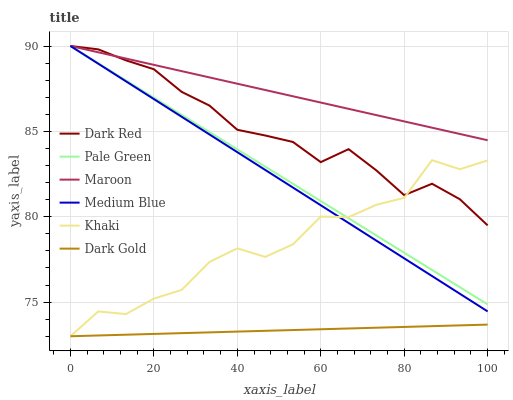Does Dark Gold have the minimum area under the curve?
Answer yes or no. Yes. Does Maroon have the maximum area under the curve?
Answer yes or no. Yes. Does Dark Red have the minimum area under the curve?
Answer yes or no. No. Does Dark Red have the maximum area under the curve?
Answer yes or no. No. Is Maroon the smoothest?
Answer yes or no. Yes. Is Khaki the roughest?
Answer yes or no. Yes. Is Dark Gold the smoothest?
Answer yes or no. No. Is Dark Gold the roughest?
Answer yes or no. No. Does Khaki have the lowest value?
Answer yes or no. Yes. Does Dark Red have the lowest value?
Answer yes or no. No. Does Pale Green have the highest value?
Answer yes or no. Yes. Does Dark Gold have the highest value?
Answer yes or no. No. Is Dark Gold less than Dark Red?
Answer yes or no. Yes. Is Pale Green greater than Dark Gold?
Answer yes or no. Yes. Does Pale Green intersect Medium Blue?
Answer yes or no. Yes. Is Pale Green less than Medium Blue?
Answer yes or no. No. Is Pale Green greater than Medium Blue?
Answer yes or no. No. Does Dark Gold intersect Dark Red?
Answer yes or no. No. 